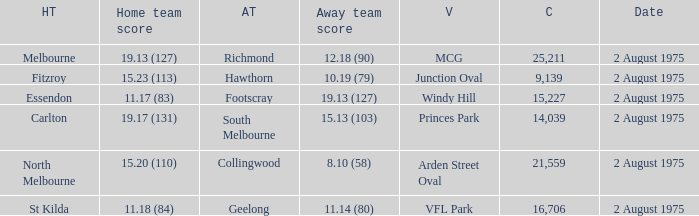When did the game at Arden Street Oval occur? 2 August 1975. 